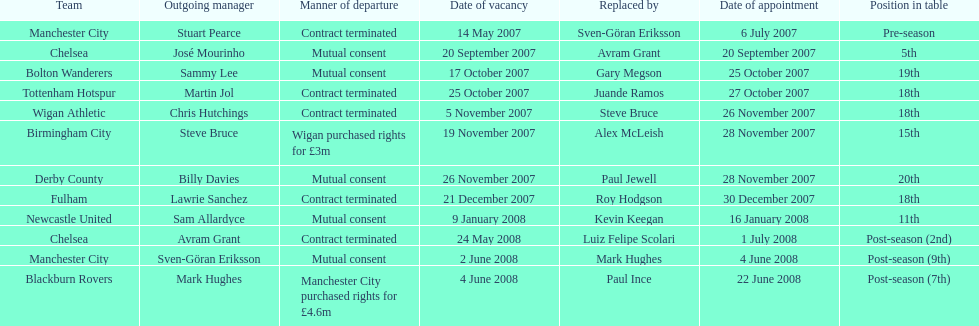After stuart pearce's departure in 2007, who took over as manchester city's manager? Sven-Göran Eriksson. 